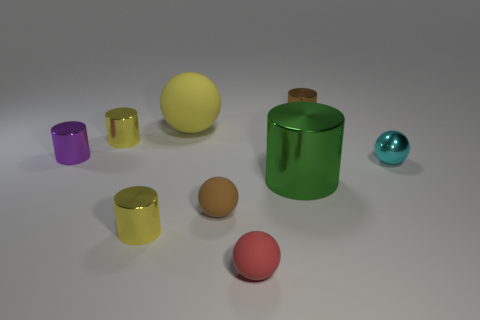Subtract all green cylinders. How many cylinders are left? 4 Subtract all brown matte balls. How many balls are left? 3 Add 1 gray metal objects. How many objects exist? 10 Subtract all cylinders. How many objects are left? 4 Subtract all green cylinders. Subtract all brown cubes. How many cylinders are left? 4 Add 9 large gray cubes. How many large gray cubes exist? 9 Subtract 0 red cylinders. How many objects are left? 9 Subtract all green objects. Subtract all small things. How many objects are left? 1 Add 8 brown cylinders. How many brown cylinders are left? 9 